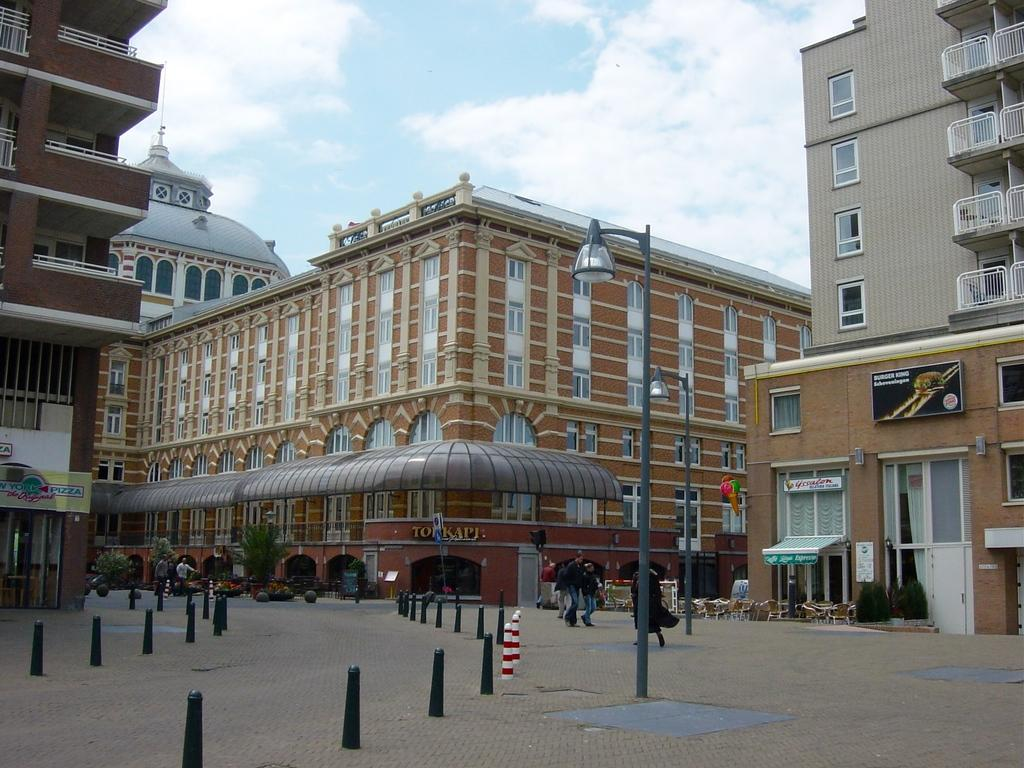What type of vertical structures can be seen in the image? There are light poles in the image. Can you describe the people in the image? There are people in the image. What type of natural elements are present in the image? There are plants and trees in the image. What type of seating is available in the image? There are chairs in the image. What type of man-made structures are present in the image? There are buildings in the image. What type of flat, rectangular objects can be seen in the image? There are boards in the image. How would you describe the sky in the image? The sky is cloudy in the image. What type of general objects are present in the image? There are objects in the image. What type of flag is flying above the copper statue in the image? There is no flag or copper statue present in the image. What type of office furniture can be seen in the image? There is no office furniture present in the image. 